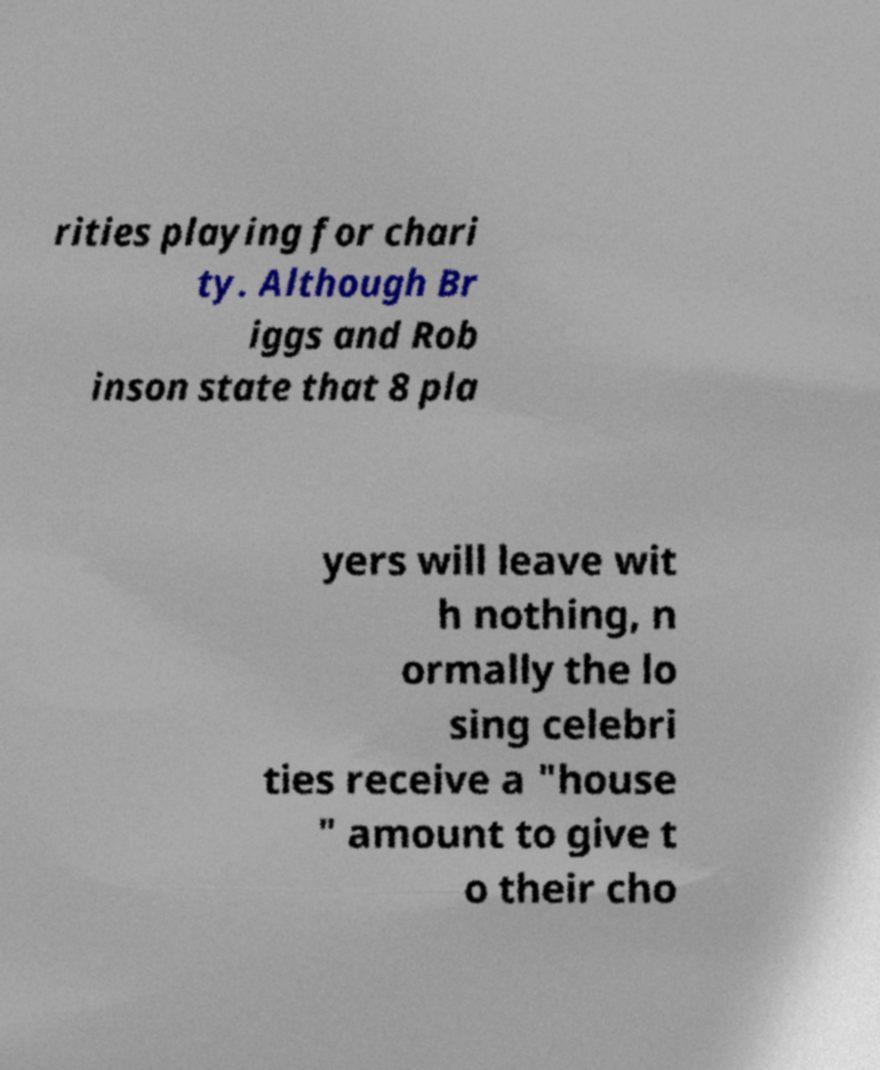Please read and relay the text visible in this image. What does it say? rities playing for chari ty. Although Br iggs and Rob inson state that 8 pla yers will leave wit h nothing, n ormally the lo sing celebri ties receive a "house " amount to give t o their cho 